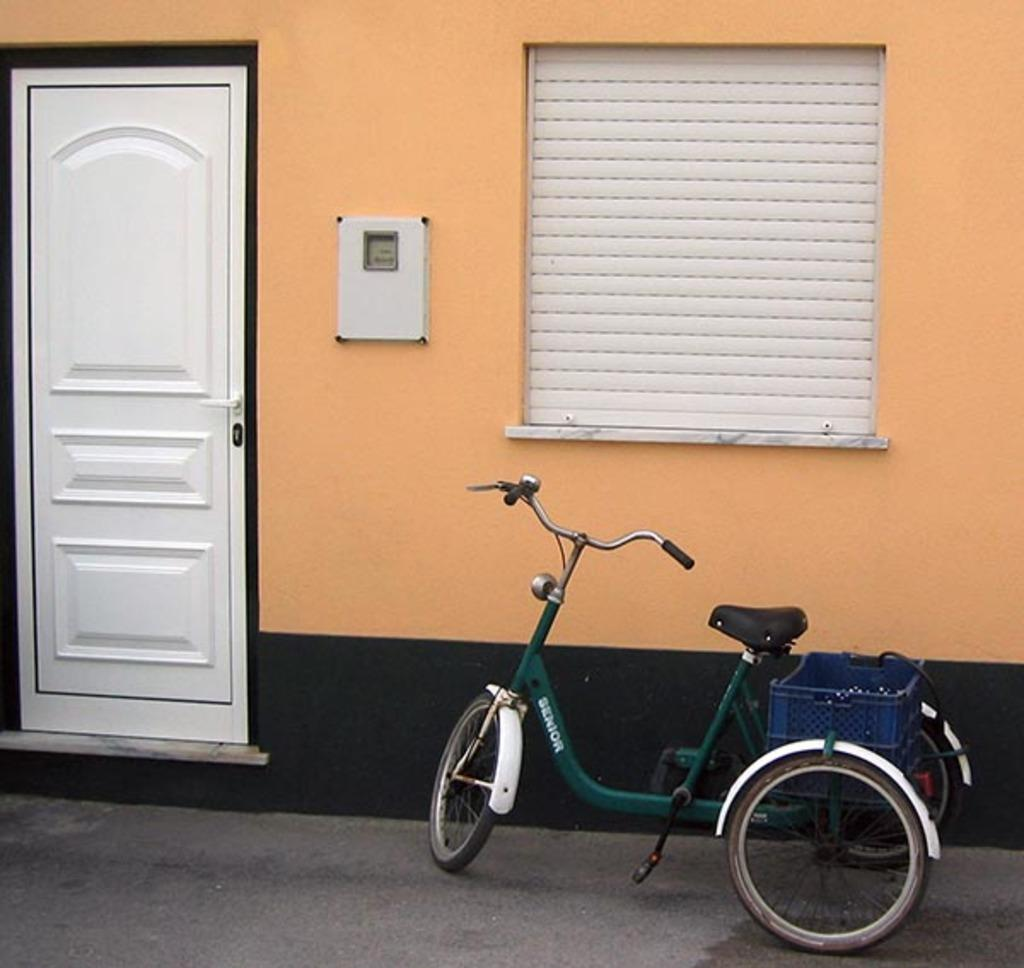What type of opening is present in the image? There is a door in the image. What can be found near the door in the image? There is a window with a window shade in the image. What is attached to the wall in the image? There is a box on the wall in the image. What can be seen on the road in the image? There is a vehicle visible on the road in the image. What type of amusement can be seen in the image? There is no amusement present in the image; it features a door, window, box, and vehicle. Can you tell me what dad is doing in the image? There is no person, let alone a dad, present in the image. What type of prose is written on the box in the image? There is no text or prose present on the box in the image. 